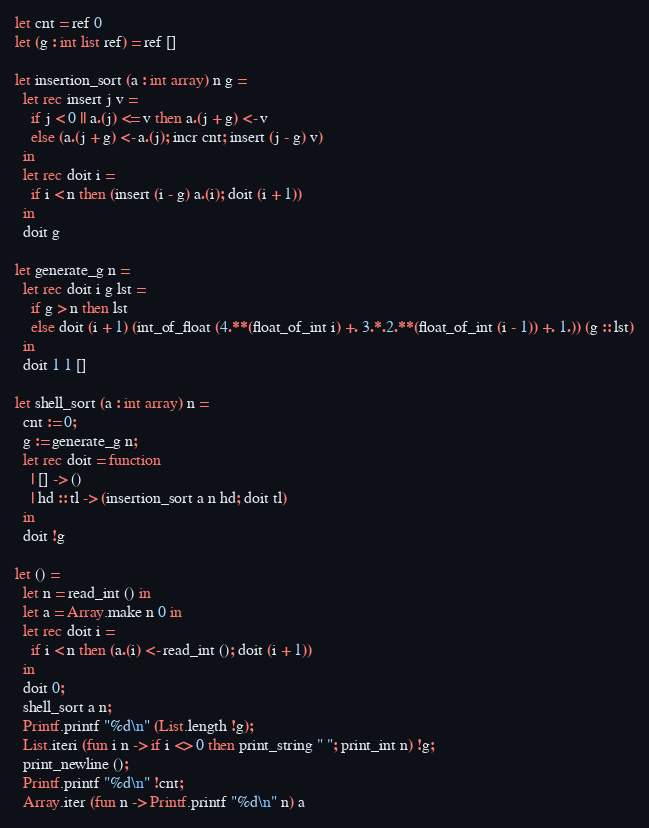Convert code to text. <code><loc_0><loc_0><loc_500><loc_500><_OCaml_>let cnt = ref 0
let (g : int list ref) = ref []

let insertion_sort (a : int array) n g =
  let rec insert j v =
    if j < 0 || a.(j) <= v then a.(j + g) <- v
    else (a.(j + g) <- a.(j); incr cnt; insert (j - g) v)
  in
  let rec doit i =
    if i < n then (insert (i - g) a.(i); doit (i + 1))
  in
  doit g

let generate_g n =
  let rec doit i g lst =
    if g > n then lst
    else doit (i + 1) (int_of_float (4.**(float_of_int i) +. 3.*.2.**(float_of_int (i - 1)) +. 1.)) (g :: lst)
  in
  doit 1 1 []

let shell_sort (a : int array) n =
  cnt := 0;
  g := generate_g n;
  let rec doit = function
    | [] -> ()
    | hd :: tl -> (insertion_sort a n hd; doit tl)
  in
  doit !g

let () =
  let n = read_int () in
  let a = Array.make n 0 in
  let rec doit i =
    if i < n then (a.(i) <- read_int (); doit (i + 1))
  in
  doit 0;
  shell_sort a n;
  Printf.printf "%d\n" (List.length !g);
  List.iteri (fun i n -> if i <> 0 then print_string " "; print_int n) !g;
  print_newline ();
  Printf.printf "%d\n" !cnt;
  Array.iter (fun n -> Printf.printf "%d\n" n) a</code> 